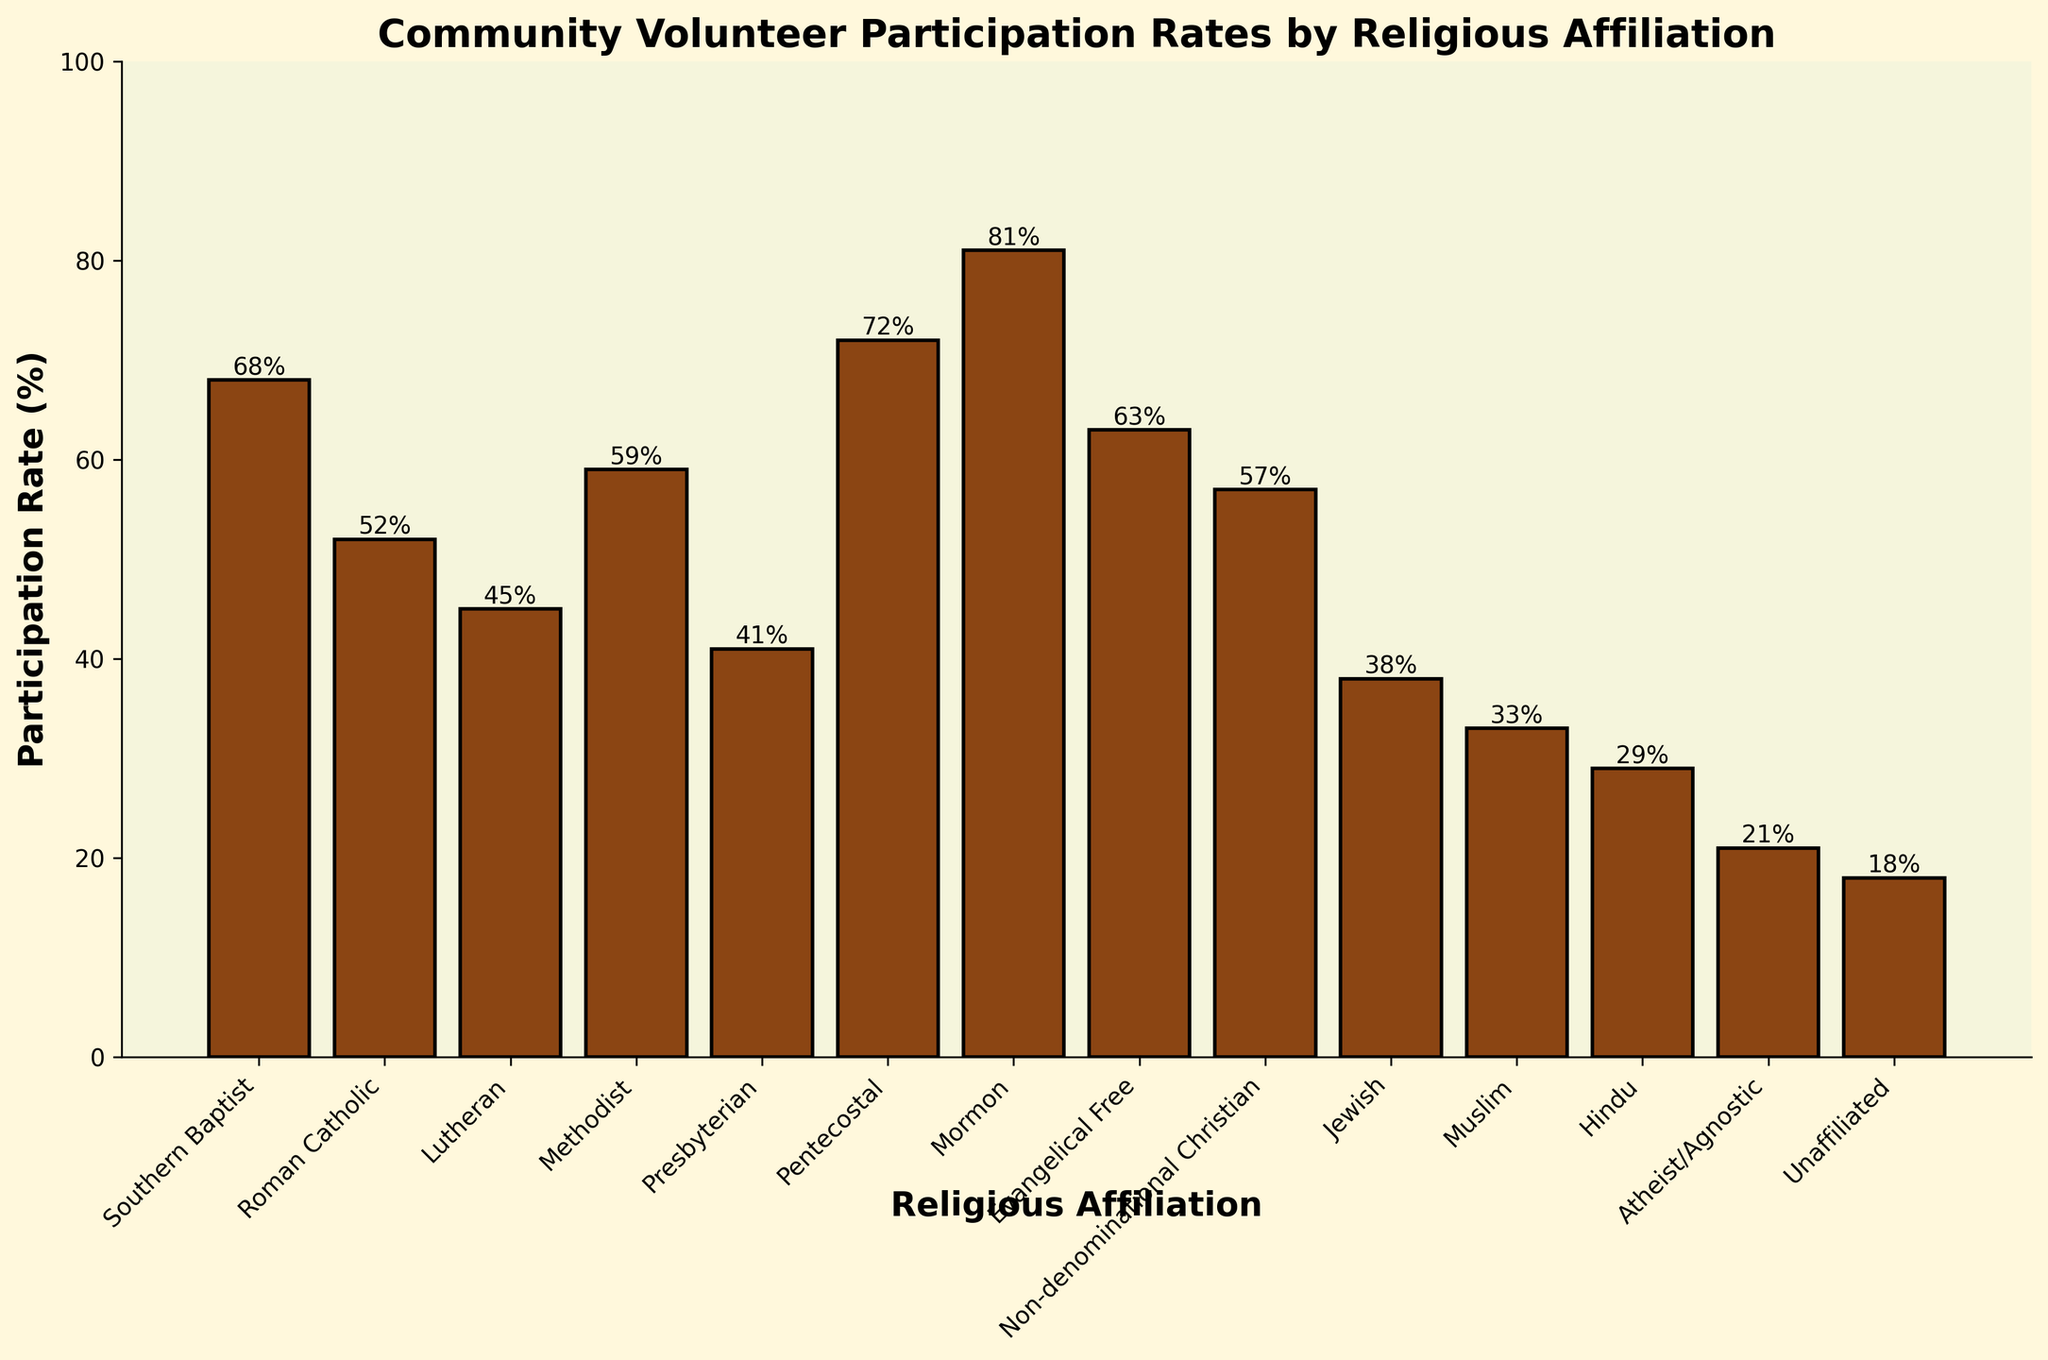Which religious affiliation has the highest volunteer participation rate? The bar for the Mormon group is the highest, indicating the highest participation rate.
Answer: Mormon How much greater is the participation rate of Southern Baptists compared to Atheist/Agnostics? The participation rate for Southern Baptists is 68%, and for Atheist/Agnostics, it is 21%. Subtracting these gives 68 - 21 = 47.
Answer: 47% What's the average participation rate for the three groups with the highest participation? The three groups with the highest participation are Mormon (81%), Pentecostal (72%), and Southern Baptist (68%). Summing these gives 81 + 72 + 68 = 221, and dividing by 3 gives an average of 221 / 3 ≈ 73.67%.
Answer: 73.67% Which group has a participation rate closest to the average participation rate for all the groups? First, sum all the participation rates and divide by the number of groups to find the average. The sum is 68 + 52 + 45 + 59 + 41 + 72 + 81 + 63 + 57 + 38 + 33 + 29 + 21 + 18 = 678. Dividing this by 14 gives an average of 678 / 14 ≈ 48.43%. The group closest to this average is Methodist with 59%.
Answer: Methodist How much higher is the participation rate of Evangelical Free compared to Roman Catholic? The participation rate for Evangelical Free is 63%, and for Roman Catholic, it is 52%. Subtracting these gives 63 - 52 = 11.
Answer: 11% What is the total participation rate for the non-Christian religious groups (Jewish, Muslim, Hindu)? Summing the participation rates for Jewish (38%), Muslim (33%), and Hindu (29%) gives 38 + 33 + 29 = 100.
Answer: 100% Which religious affiliation has the lowest volunteer participation rate, and what is it? The bar for Unaffiliated is the shortest, indicating the lowest participation rate, which is 18%.
Answer: Unaffiliated, 18% How does the participation rate of Methodists compare to that of Non-denominational Christians? The participation rate for Methodists is 59%, and for Non-denominational Christians, it is 57%. 59% is 2% higher than 57%.
Answer: Methodists' rate is 2% higher What is the difference in participation rates between the group with the highest and the group with the lowest rates? The group with the highest participation rate is Mormon (81%), and the group with the lowest rate is Unaffiliated (18%). Subtracting these gives 81 - 18 = 63.
Answer: 63% 